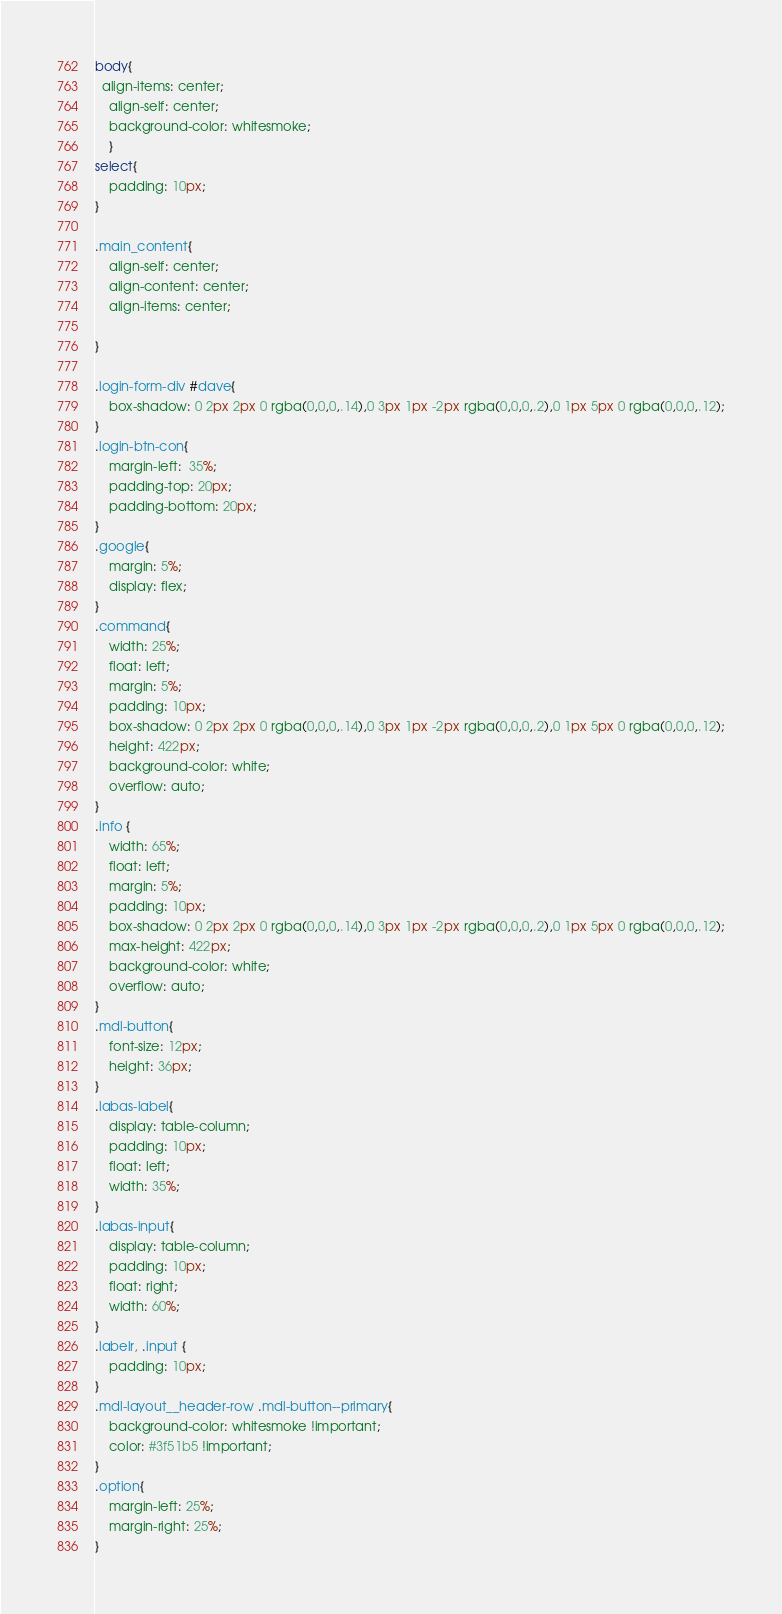<code> <loc_0><loc_0><loc_500><loc_500><_CSS_>body{
  align-items: center;
    align-self: center;
    background-color: whitesmoke;
    }
select{
    padding: 10px;
}

.main_content{
    align-self: center;
    align-content: center;
    align-items: center;

}

.login-form-div #dave{
    box-shadow: 0 2px 2px 0 rgba(0,0,0,.14),0 3px 1px -2px rgba(0,0,0,.2),0 1px 5px 0 rgba(0,0,0,.12);
}
.login-btn-con{
    margin-left:  35%;
    padding-top: 20px;
    padding-bottom: 20px;
}
.google{
    margin: 5%;
    display: flex;
}
.command{
    width: 25%;
    float: left;
    margin: 5%;
    padding: 10px;
    box-shadow: 0 2px 2px 0 rgba(0,0,0,.14),0 3px 1px -2px rgba(0,0,0,.2),0 1px 5px 0 rgba(0,0,0,.12);
    height: 422px;
    background-color: white;
    overflow: auto;
}
.info {
    width: 65%;
    float: left;
    margin: 5%;
    padding: 10px;
    box-shadow: 0 2px 2px 0 rgba(0,0,0,.14),0 3px 1px -2px rgba(0,0,0,.2),0 1px 5px 0 rgba(0,0,0,.12);
    max-height: 422px;
    background-color: white;
    overflow: auto;
}
.mdl-button{
    font-size: 12px;
    height: 36px;
}
.labas-label{
    display: table-column;
    padding: 10px;
    float: left;
    width: 35%;
}
.labas-input{
    display: table-column;
    padding: 10px;
    float: right;
    width: 60%;
}
.labelr, .input {
    padding: 10px;
}
.mdl-layout__header-row .mdl-button--primary{
    background-color: whitesmoke !important;
    color: #3f51b5 !important;
}
.option{
    margin-left: 25%;
    margin-right: 25%;
}</code> 